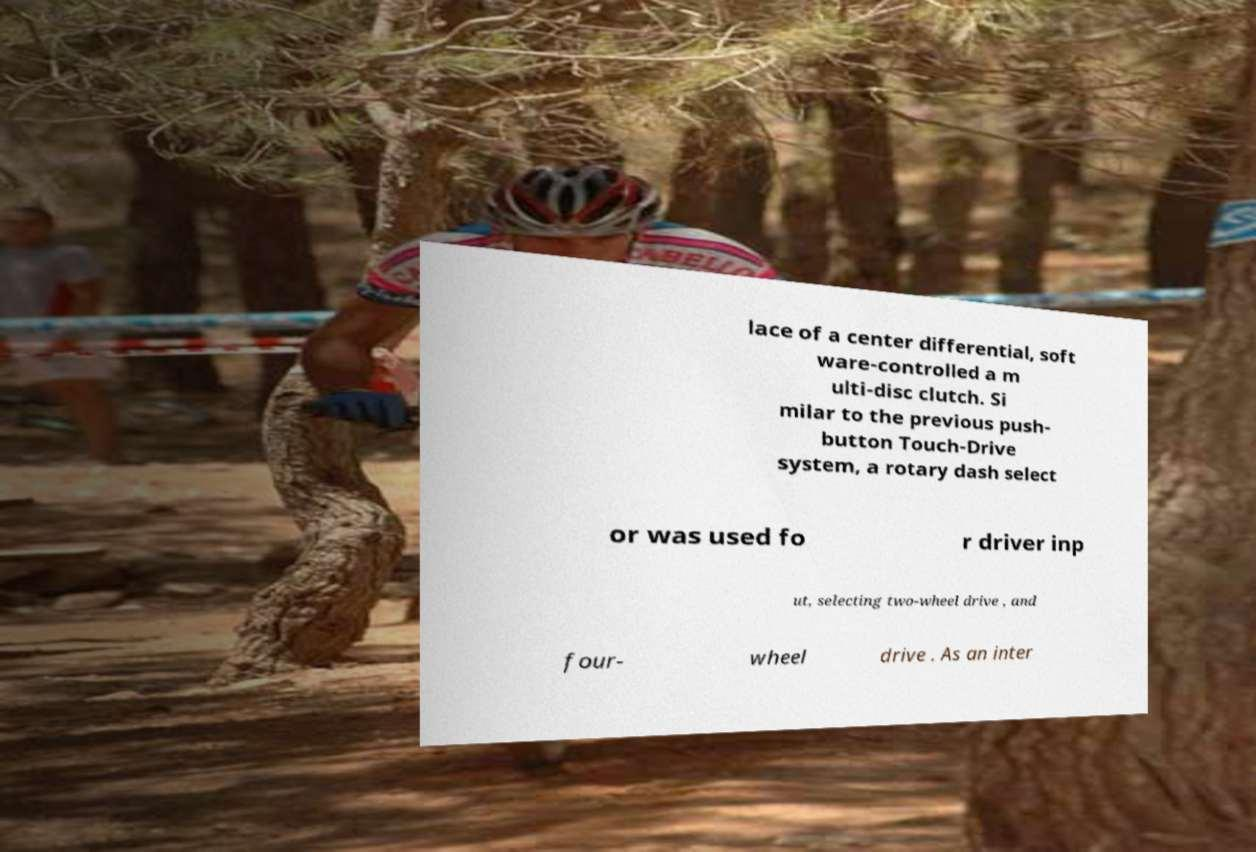Please identify and transcribe the text found in this image. lace of a center differential, soft ware-controlled a m ulti-disc clutch. Si milar to the previous push- button Touch-Drive system, a rotary dash select or was used fo r driver inp ut, selecting two-wheel drive , and four- wheel drive . As an inter 